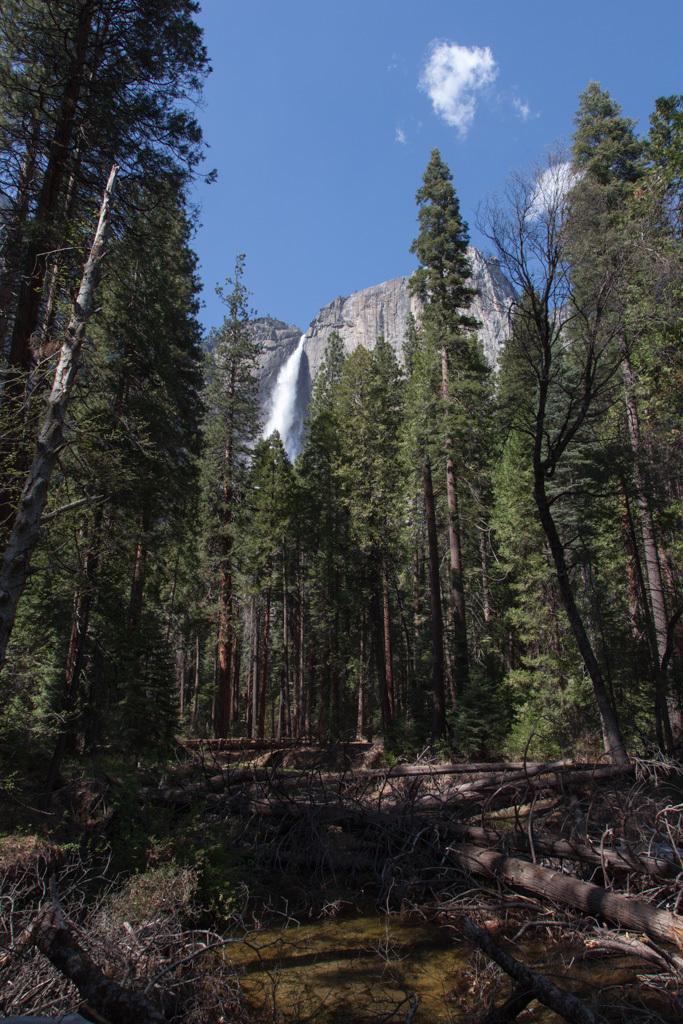Can you describe this image briefly? In front of the image there is water, dry branches and wooden logs on the surface. Behind them there are trees and mountains. In the background of the image there is a waterfall. At the top of the image there are clouds in the sky. 